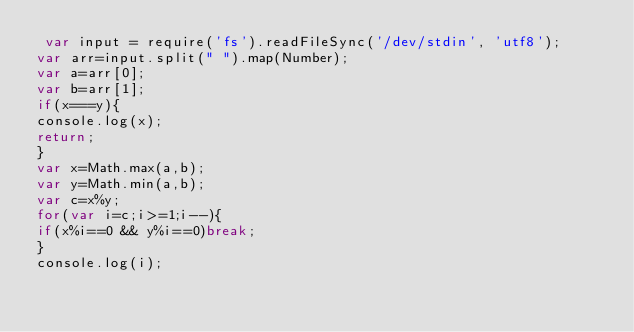<code> <loc_0><loc_0><loc_500><loc_500><_JavaScript_> var input = require('fs').readFileSync('/dev/stdin', 'utf8');
var arr=input.split(" ").map(Number);
var a=arr[0];
var b=arr[1];
if(x===y){
console.log(x);
return;
}
var x=Math.max(a,b);
var y=Math.min(a,b);
var c=x%y;
for(var i=c;i>=1;i--){
if(x%i==0 && y%i==0)break;
}
console.log(i);</code> 